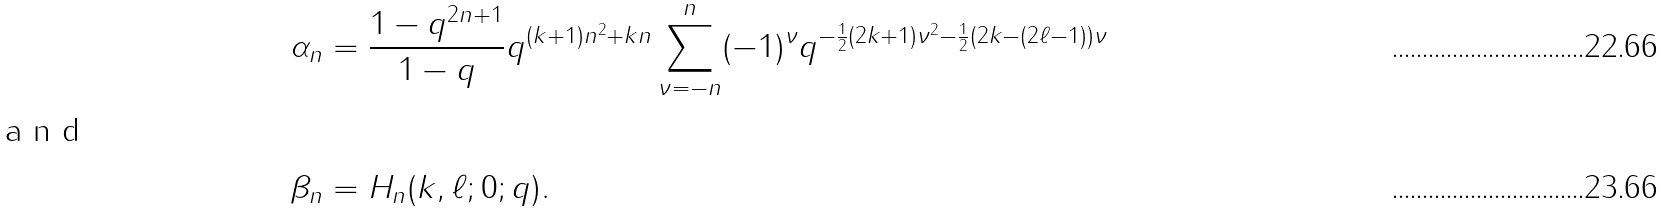<formula> <loc_0><loc_0><loc_500><loc_500>\alpha _ { n } & = \frac { 1 - q ^ { 2 n + 1 } } { 1 - q } q ^ { ( k + 1 ) n ^ { 2 } + k n } \sum _ { \nu = - n } ^ { n } ( - 1 ) ^ { \nu } q ^ { - \frac { 1 } { 2 } ( 2 k + 1 ) \nu ^ { 2 } - \frac { 1 } { 2 } ( 2 k - ( 2 \ell - 1 ) ) \nu } \\ \intertext { a n d } \beta _ { n } & = H _ { n } ( k , \ell ; 0 ; q ) .</formula> 